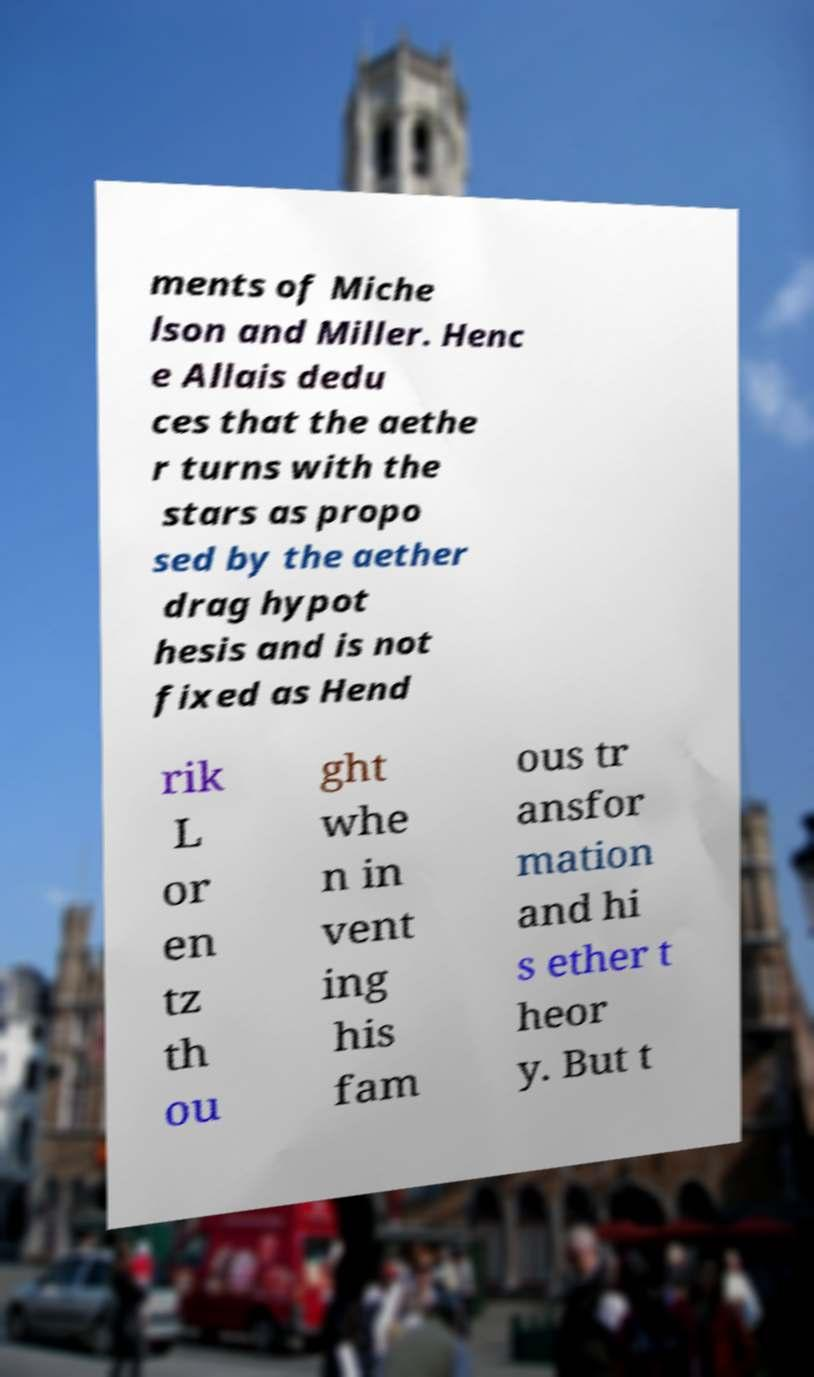Could you assist in decoding the text presented in this image and type it out clearly? ments of Miche lson and Miller. Henc e Allais dedu ces that the aethe r turns with the stars as propo sed by the aether drag hypot hesis and is not fixed as Hend rik L or en tz th ou ght whe n in vent ing his fam ous tr ansfor mation and hi s ether t heor y. But t 